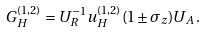Convert formula to latex. <formula><loc_0><loc_0><loc_500><loc_500>G _ { H } ^ { ( 1 , 2 ) } = U _ { R } ^ { - 1 } u _ { H } ^ { ( 1 , 2 ) } ( 1 \pm \sigma _ { z } ) U _ { A } \, .</formula> 